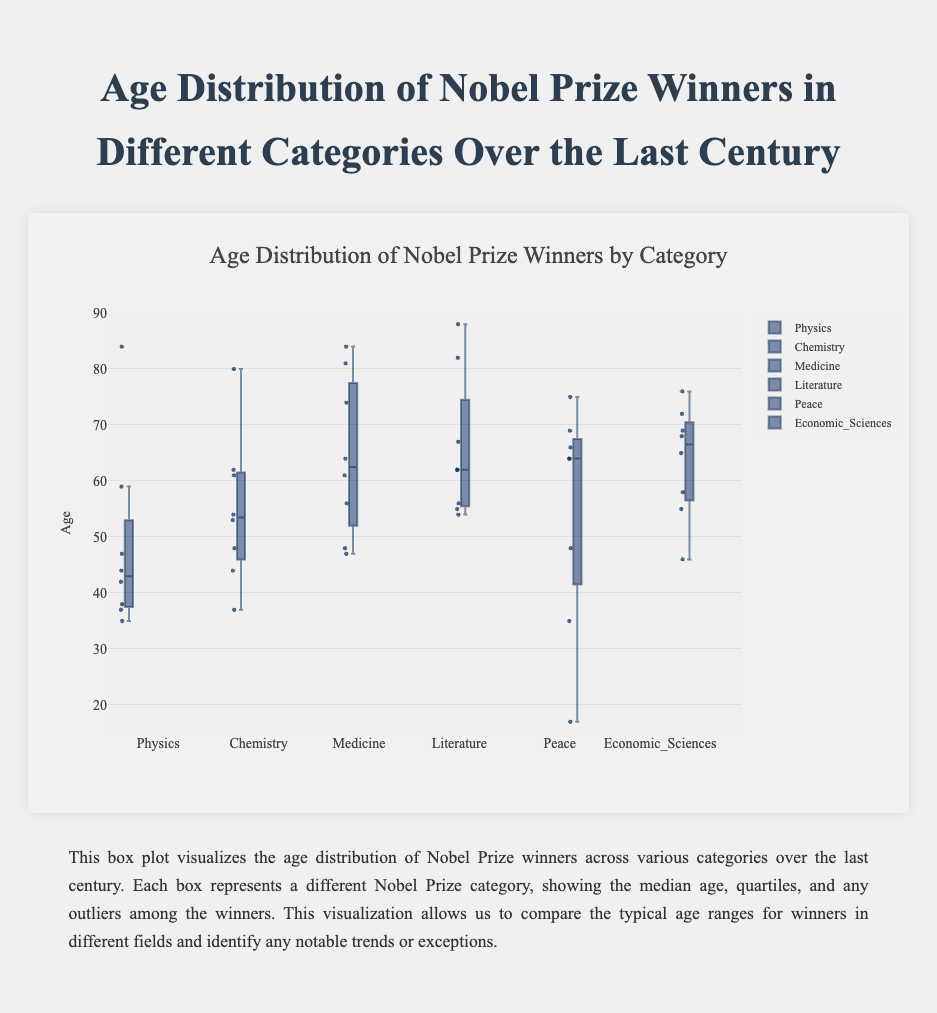How many categories of Nobel Prizes are displayed in the plot? Count the number of boxes, each representing a different category of Nobel Prize.
Answer: 6 What is the median age of Nobel Prize winners in Chemistry? Find the line in the middle of the box for the Chemistry category, which represents the median age.
Answer: 53.5 Which category has the youngest Nobel Prize winner, and what is the age? Look for the lowest point in all boxes and identify the corresponding category and age.
Answer: Peace, 17 What is the range of ages for Nobel Prize winners in Literature? Find the top and bottom points of the Literature box. Subtract the youngest age (54) from the oldest age (88).
Answer: 34 Which category has the widest age distribution according to the box plot? Compare the ranges of the boxes. The category with the largest range between the minimum and maximum points has the widest age distribution.
Answer: Literature Which category has the smallest range of ages? Compare the ranges of the boxes. The category with the smallest range between the minimum and maximum points has the smallest age distribution.
Answer: Economic Sciences Are there any categories that have outliers? If yes, name them. Identify any points plotted outside the whiskers of the box plots, which indicate outliers.
Answer: Yes, Physics How does the median age of Peace Prize winners compare to that of Medicine Prize winners? Find the median age lines in the boxes for both the Peace and Medicine categories, then compare them.
Answer: Median age in Peace is lower than Medicine What is the difference between the median ages of Literature and Economic Sciences winners? Find the median lines in the Literature and Economic Sciences boxes and subtract the latter from the former.
Answer: 8 (62 - 54) Which category of winners tends to be awarded later in life, and what indicates this? Check the median ages across all categories; the category with the highest median indicates that winners are awarded later in life.
Answer: Literature 